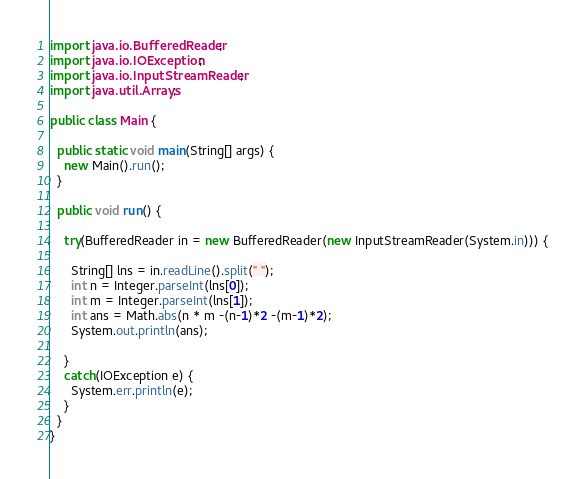<code> <loc_0><loc_0><loc_500><loc_500><_Java_>import java.io.BufferedReader;
import java.io.IOException;
import java.io.InputStreamReader;
import java.util.Arrays;

public class Main {

  public static void main(String[] args) {
    new Main().run();
  }

  public void run() {

    try(BufferedReader in = new BufferedReader(new InputStreamReader(System.in))) {

      String[] lns = in.readLine().split(" ");
      int n = Integer.parseInt(lns[0]);
      int m = Integer.parseInt(lns[1]);
      int ans = Math.abs(n * m -(n-1)*2 -(m-1)*2);
      System.out.println(ans);

    }
    catch(IOException e) {
      System.err.println(e);
    }
  }
}</code> 